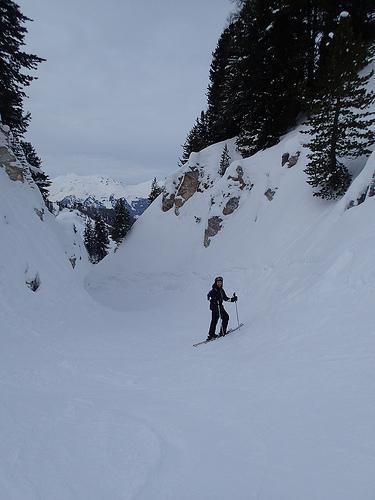How many people are in the photo?
Give a very brief answer. 1. 